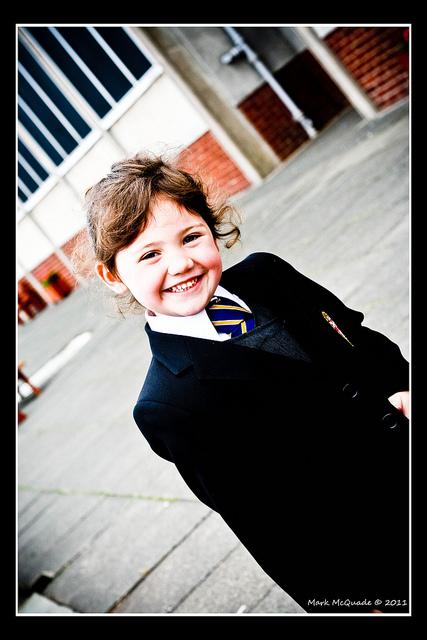Who in the foto?
Give a very brief answer. Girl. Is she wearing a school uniform?
Write a very short answer. Yes. Is the girl happy?
Answer briefly. Yes. 